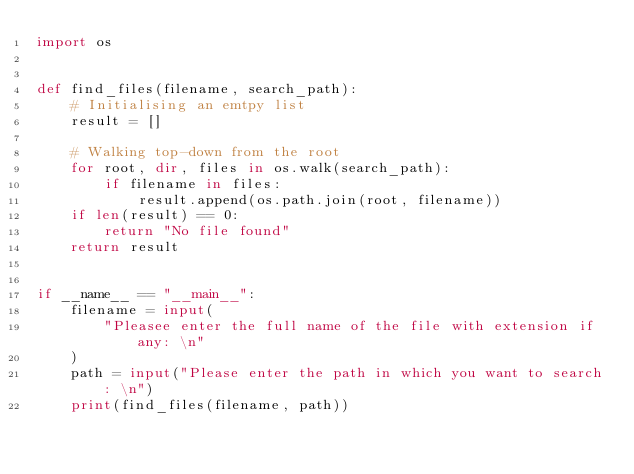<code> <loc_0><loc_0><loc_500><loc_500><_Python_>import os


def find_files(filename, search_path):
    # Initialising an emtpy list
    result = []

    # Walking top-down from the root
    for root, dir, files in os.walk(search_path):
        if filename in files:
            result.append(os.path.join(root, filename))
    if len(result) == 0:
        return "No file found"
    return result


if __name__ == "__main__":
    filename = input(
        "Pleasee enter the full name of the file with extension if any: \n"
    )
    path = input("Please enter the path in which you want to search: \n")
    print(find_files(filename, path))
</code> 